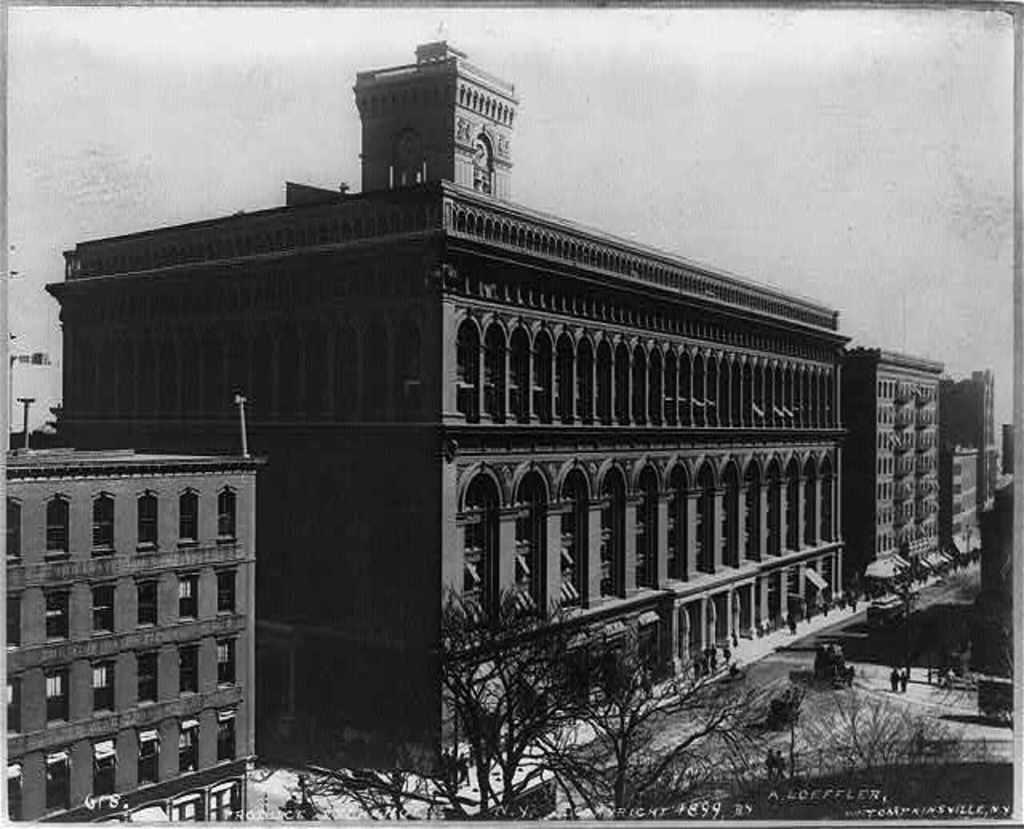Could you give a brief overview of what you see in this image? In this image there is a big building in front of that there are so many trees and some people standing on the road. 